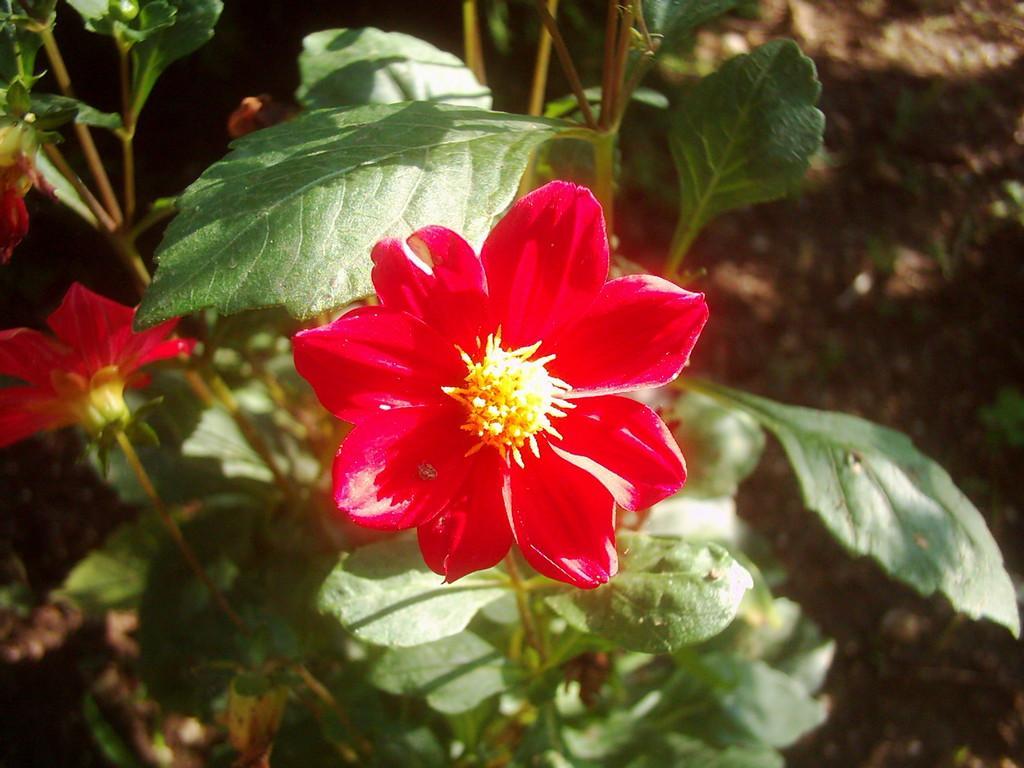Can you describe this image briefly? In this image there are plants and we can see flowers which are in red color. 